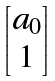Convert formula to latex. <formula><loc_0><loc_0><loc_500><loc_500>\begin{bmatrix} a _ { 0 } \\ 1 \end{bmatrix}</formula> 